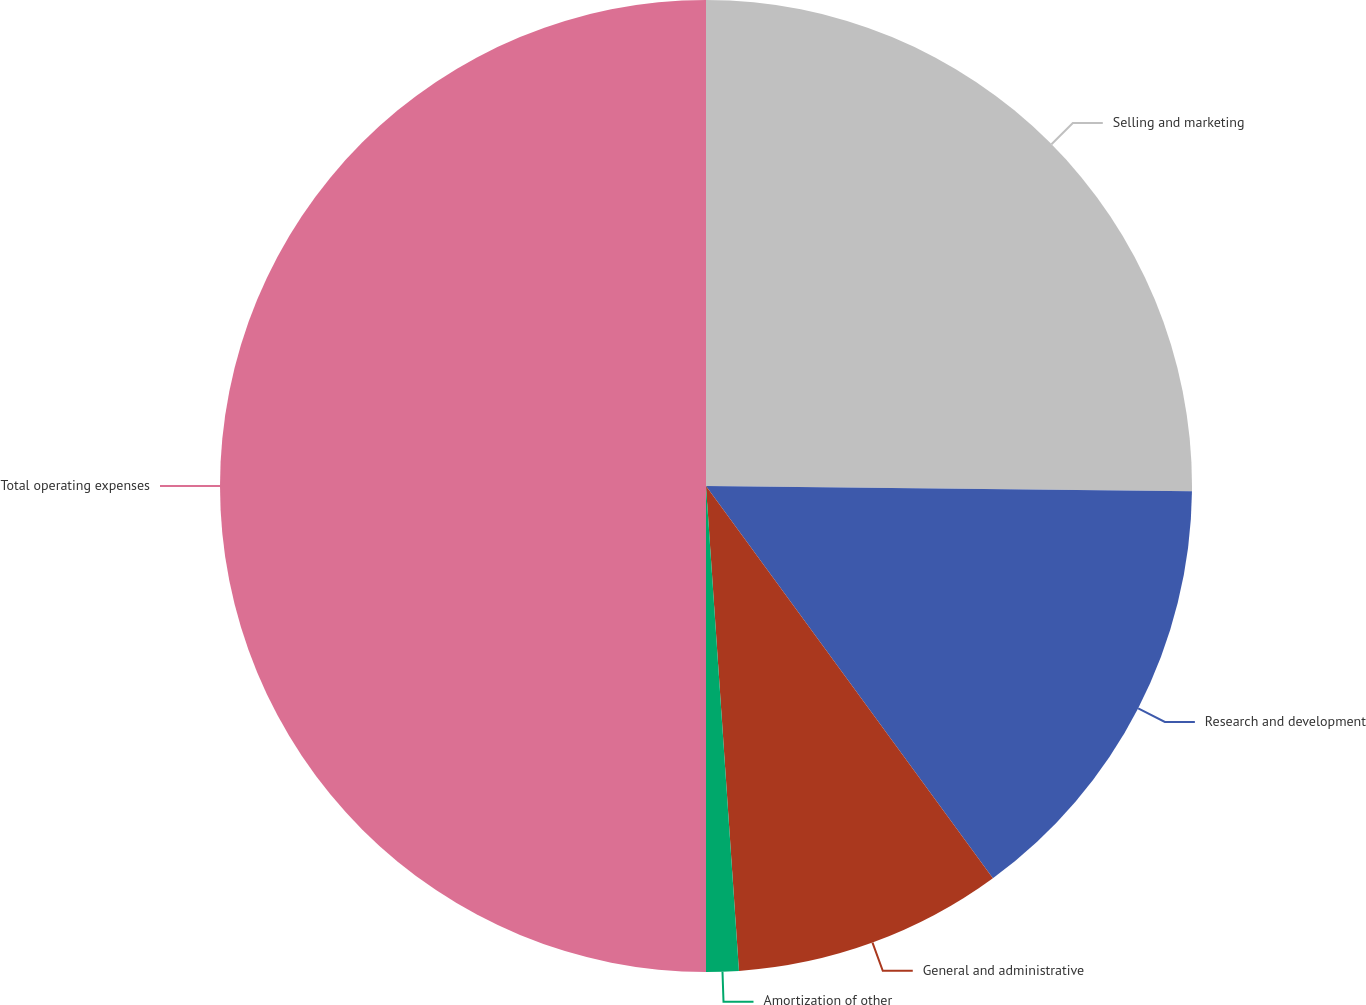<chart> <loc_0><loc_0><loc_500><loc_500><pie_chart><fcel>Selling and marketing<fcel>Research and development<fcel>General and administrative<fcel>Amortization of other<fcel>Total operating expenses<nl><fcel>25.17%<fcel>14.78%<fcel>8.97%<fcel>1.08%<fcel>50.0%<nl></chart> 